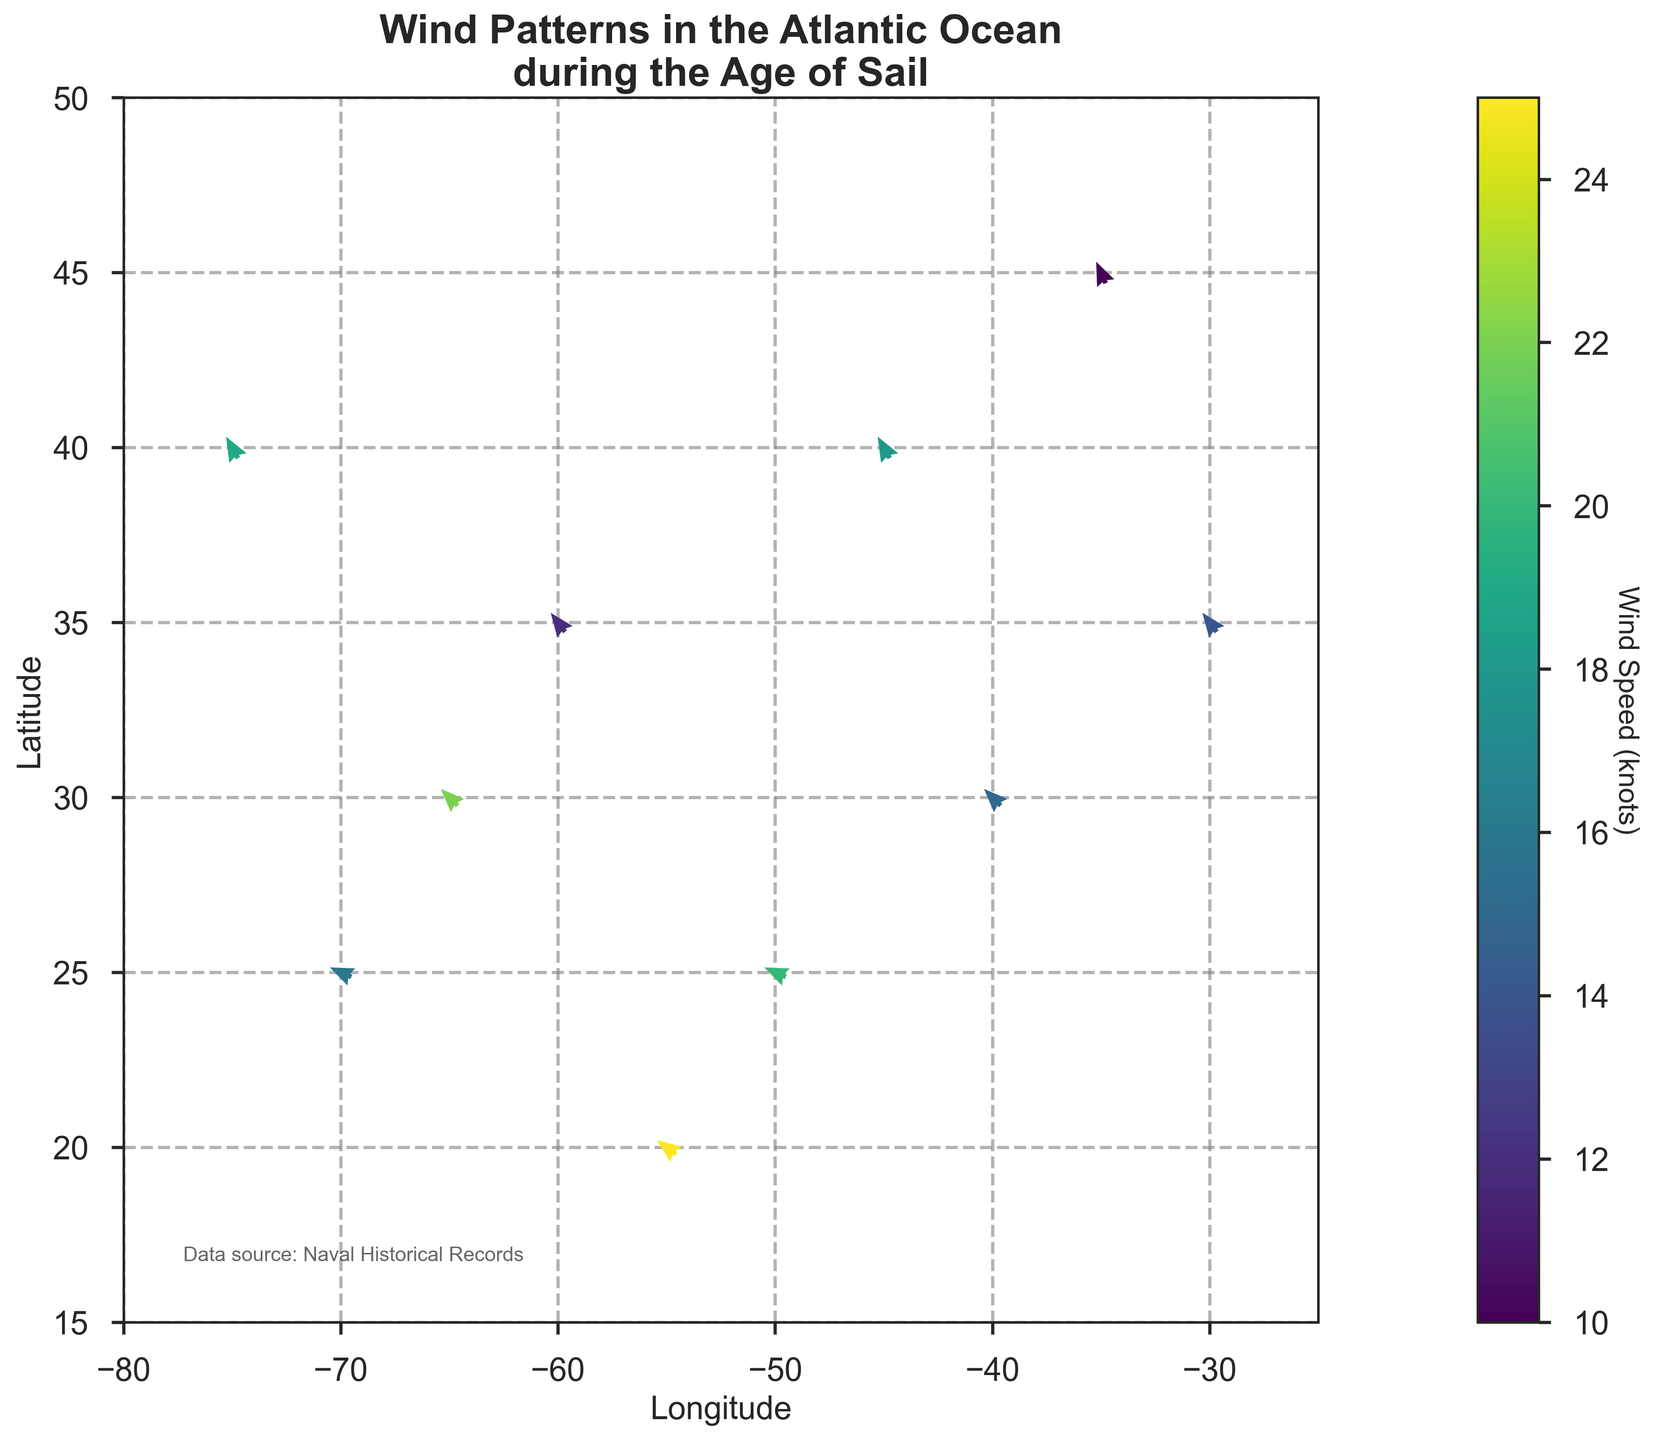What's the title of the figure? The title of the figure is displayed at the top and reads 'Wind Patterns in the Atlantic Ocean during the Age of Sail'.
Answer: Wind Patterns in the Atlantic Ocean during the Age of Sail How many data points are displayed in the figure? Each arrow represents one data point. Counting the arrows in the plot, we find there are 10 data points.
Answer: 10 What range of wind speeds is shown in the colorbar? The colorbar indicates the wind speeds by color, ranging from the lowest value of 10 knots to the highest value of 25 knots.
Answer: 10 to 25 knots Which location experiences the highest wind speed? The color of the arrows indicates wind speed, with the darkest color representing the highest speed. The arrow at longitude -55 and latitude 20 is the darkest, indicating the highest wind speed of 25 knots.
Answer: -55, 20 How are wind directions depicted in the figure? The direction of the arrows shows the wind direction, with the base of the arrow indicating the origin and the head pointing towards the direction the wind is blowing.
Answer: Arrow direction At which latitude do we observe the most varied wind directions? Observing the wind directions at different latitudes, the latitude of 30 shows winds coming from various directions as demonstrated by the arrows at different longitudes (-40, -65).
Answer: 30 Compare the wind speeds at longitude -40, latitude 30 and longitude -30, latitude 35. Which is higher? The colors of the arrows indicate wind speeds. The arrow at -40, 30 is darker than the one at -30, 35, indicating a higher wind speed. The respective wind speeds are 15 knots and 14 knots.
Answer: -40, 30 What is the average wind speed for the data points shown in the figure? Summing the wind speeds: 15 + 20 + 12 + 18 + 25 + 10 + 22 + 16 + 14 + 19 = 171. We have 10 data points, so the average is 171/10 = 17.1 knots.
Answer: 17.1 knots Which location on the plot has the most northerly wind (wind coming directly from the south)? The most northerly wind will have its y-component, wind_direction_y, closest to 1. The arrows at longitudes -35, -45, -75, and -45 show the most northerly direction with wind_direction_y values close to 0.9.
Answer: -35, 45 Is there a location where the wind direction is almost purely westerly? A westerly wind direction would have a wind_direction_x component close to -1 and wind_direction_y close to 0. The arrow at longitude -70, latitude 25 best fits this description with wind directions of -0.9, 0.4.
Answer: -70, 25 